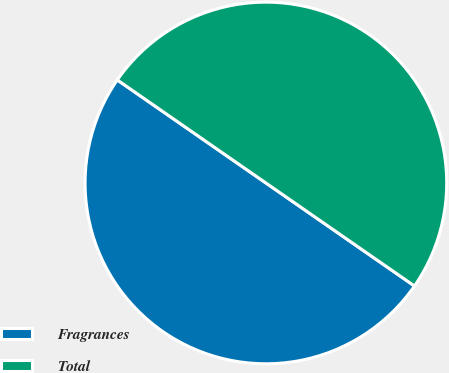<chart> <loc_0><loc_0><loc_500><loc_500><pie_chart><fcel>Fragrances<fcel>Total<nl><fcel>50.0%<fcel>50.0%<nl></chart> 